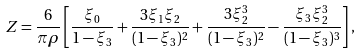Convert formula to latex. <formula><loc_0><loc_0><loc_500><loc_500>Z = \frac { 6 } { \pi \rho } \left [ \frac { \xi _ { 0 } } { 1 - \xi _ { 3 } } + \frac { 3 \xi _ { 1 } \xi _ { 2 } } { ( 1 - \xi _ { 3 } ) ^ { 2 } } + \frac { 3 \xi _ { 2 } ^ { 3 } } { ( 1 - \xi _ { 3 } ) ^ { 2 } } - \frac { \xi _ { 3 } \xi _ { 2 } ^ { 3 } } { ( 1 - \xi _ { 3 } ) ^ { 3 } } \right ] ,</formula> 